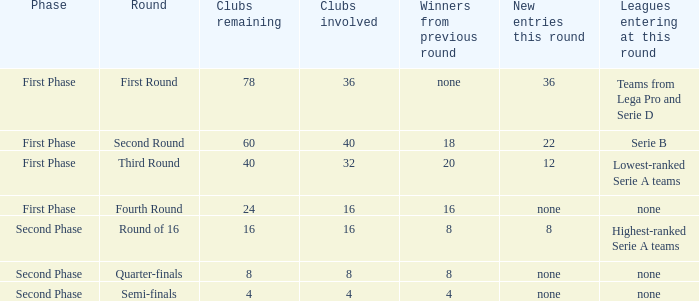From the round name of third round; what would the new entries this round that would be found? 12.0. 